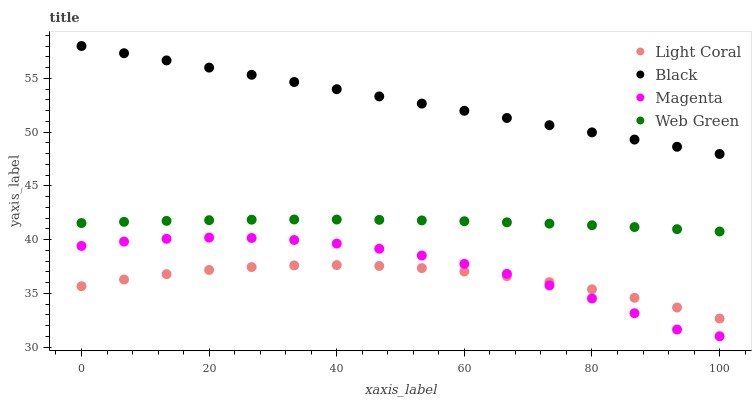Does Light Coral have the minimum area under the curve?
Answer yes or no. Yes. Does Black have the maximum area under the curve?
Answer yes or no. Yes. Does Magenta have the minimum area under the curve?
Answer yes or no. No. Does Magenta have the maximum area under the curve?
Answer yes or no. No. Is Black the smoothest?
Answer yes or no. Yes. Is Magenta the roughest?
Answer yes or no. Yes. Is Magenta the smoothest?
Answer yes or no. No. Is Black the roughest?
Answer yes or no. No. Does Magenta have the lowest value?
Answer yes or no. Yes. Does Black have the lowest value?
Answer yes or no. No. Does Black have the highest value?
Answer yes or no. Yes. Does Magenta have the highest value?
Answer yes or no. No. Is Light Coral less than Web Green?
Answer yes or no. Yes. Is Black greater than Web Green?
Answer yes or no. Yes. Does Magenta intersect Light Coral?
Answer yes or no. Yes. Is Magenta less than Light Coral?
Answer yes or no. No. Is Magenta greater than Light Coral?
Answer yes or no. No. Does Light Coral intersect Web Green?
Answer yes or no. No. 